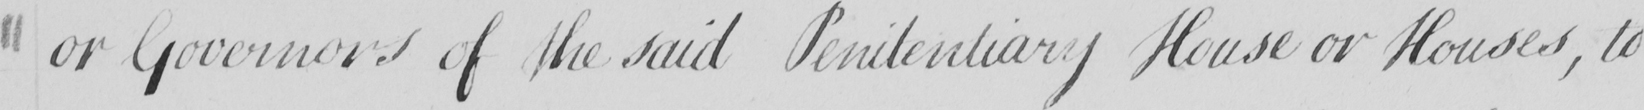Can you tell me what this handwritten text says? or Governors of the said Penitentiary House or Houses , to 